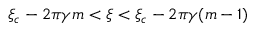<formula> <loc_0><loc_0><loc_500><loc_500>\xi _ { c } - 2 \pi \gamma m < \xi < \xi _ { c } - 2 \pi \gamma ( m - 1 )</formula> 